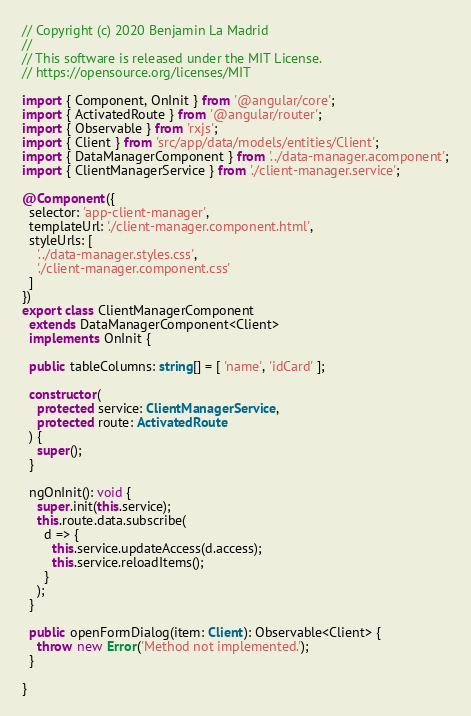Convert code to text. <code><loc_0><loc_0><loc_500><loc_500><_TypeScript_>// Copyright (c) 2020 Benjamin La Madrid
//
// This software is released under the MIT License.
// https://opensource.org/licenses/MIT

import { Component, OnInit } from '@angular/core';
import { ActivatedRoute } from '@angular/router';
import { Observable } from 'rxjs';
import { Client } from 'src/app/data/models/entities/Client';
import { DataManagerComponent } from '../data-manager.acomponent';
import { ClientManagerService } from './client-manager.service';

@Component({
  selector: 'app-client-manager',
  templateUrl: './client-manager.component.html',
  styleUrls: [
    '../data-manager.styles.css',
    './client-manager.component.css'
  ]
})
export class ClientManagerComponent
  extends DataManagerComponent<Client>
  implements OnInit {

  public tableColumns: string[] = [ 'name', 'idCard' ];

  constructor(
    protected service: ClientManagerService,
    protected route: ActivatedRoute
  ) {
    super();
  }

  ngOnInit(): void {
    super.init(this.service);
    this.route.data.subscribe(
      d => {
        this.service.updateAccess(d.access);
        this.service.reloadItems();
      }
    );
  }

  public openFormDialog(item: Client): Observable<Client> {
    throw new Error('Method not implemented.');
  }

}
</code> 